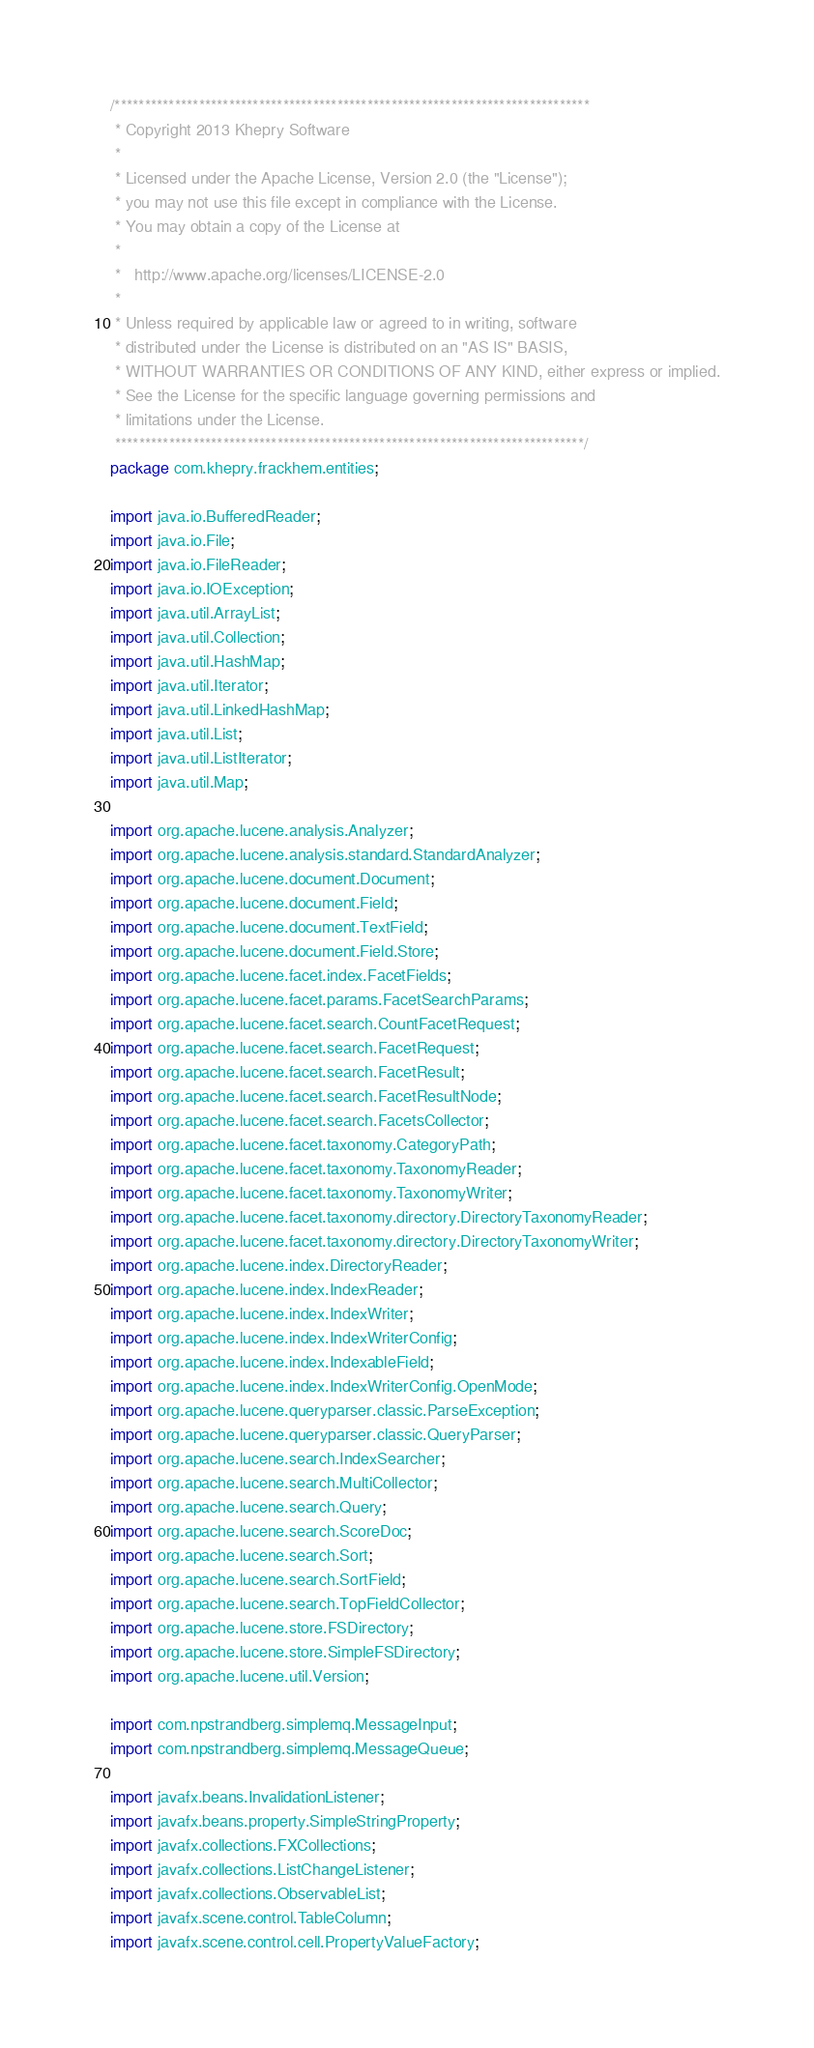<code> <loc_0><loc_0><loc_500><loc_500><_Java_>/*******************************************************************************
 * Copyright 2013 Khepry Software
 * 
 * Licensed under the Apache License, Version 2.0 (the "License");
 * you may not use this file except in compliance with the License.
 * You may obtain a copy of the License at
 * 
 *   http://www.apache.org/licenses/LICENSE-2.0
 * 
 * Unless required by applicable law or agreed to in writing, software
 * distributed under the License is distributed on an "AS IS" BASIS,
 * WITHOUT WARRANTIES OR CONDITIONS OF ANY KIND, either express or implied.
 * See the License for the specific language governing permissions and
 * limitations under the License.
 ******************************************************************************/
package com.khepry.frackhem.entities;

import java.io.BufferedReader;
import java.io.File;
import java.io.FileReader;
import java.io.IOException;
import java.util.ArrayList;
import java.util.Collection;
import java.util.HashMap;
import java.util.Iterator;
import java.util.LinkedHashMap;
import java.util.List;
import java.util.ListIterator;
import java.util.Map;

import org.apache.lucene.analysis.Analyzer;
import org.apache.lucene.analysis.standard.StandardAnalyzer;
import org.apache.lucene.document.Document;
import org.apache.lucene.document.Field;
import org.apache.lucene.document.TextField;
import org.apache.lucene.document.Field.Store;
import org.apache.lucene.facet.index.FacetFields;
import org.apache.lucene.facet.params.FacetSearchParams;
import org.apache.lucene.facet.search.CountFacetRequest;
import org.apache.lucene.facet.search.FacetRequest;
import org.apache.lucene.facet.search.FacetResult;
import org.apache.lucene.facet.search.FacetResultNode;
import org.apache.lucene.facet.search.FacetsCollector;
import org.apache.lucene.facet.taxonomy.CategoryPath;
import org.apache.lucene.facet.taxonomy.TaxonomyReader;
import org.apache.lucene.facet.taxonomy.TaxonomyWriter;
import org.apache.lucene.facet.taxonomy.directory.DirectoryTaxonomyReader;
import org.apache.lucene.facet.taxonomy.directory.DirectoryTaxonomyWriter;
import org.apache.lucene.index.DirectoryReader;
import org.apache.lucene.index.IndexReader;
import org.apache.lucene.index.IndexWriter;
import org.apache.lucene.index.IndexWriterConfig;
import org.apache.lucene.index.IndexableField;
import org.apache.lucene.index.IndexWriterConfig.OpenMode;
import org.apache.lucene.queryparser.classic.ParseException;
import org.apache.lucene.queryparser.classic.QueryParser;
import org.apache.lucene.search.IndexSearcher;
import org.apache.lucene.search.MultiCollector;
import org.apache.lucene.search.Query;
import org.apache.lucene.search.ScoreDoc;
import org.apache.lucene.search.Sort;
import org.apache.lucene.search.SortField;
import org.apache.lucene.search.TopFieldCollector;
import org.apache.lucene.store.FSDirectory;
import org.apache.lucene.store.SimpleFSDirectory;
import org.apache.lucene.util.Version;

import com.npstrandberg.simplemq.MessageInput;
import com.npstrandberg.simplemq.MessageQueue;

import javafx.beans.InvalidationListener;
import javafx.beans.property.SimpleStringProperty;
import javafx.collections.FXCollections;
import javafx.collections.ListChangeListener;
import javafx.collections.ObservableList;
import javafx.scene.control.TableColumn;
import javafx.scene.control.cell.PropertyValueFactory;
</code> 